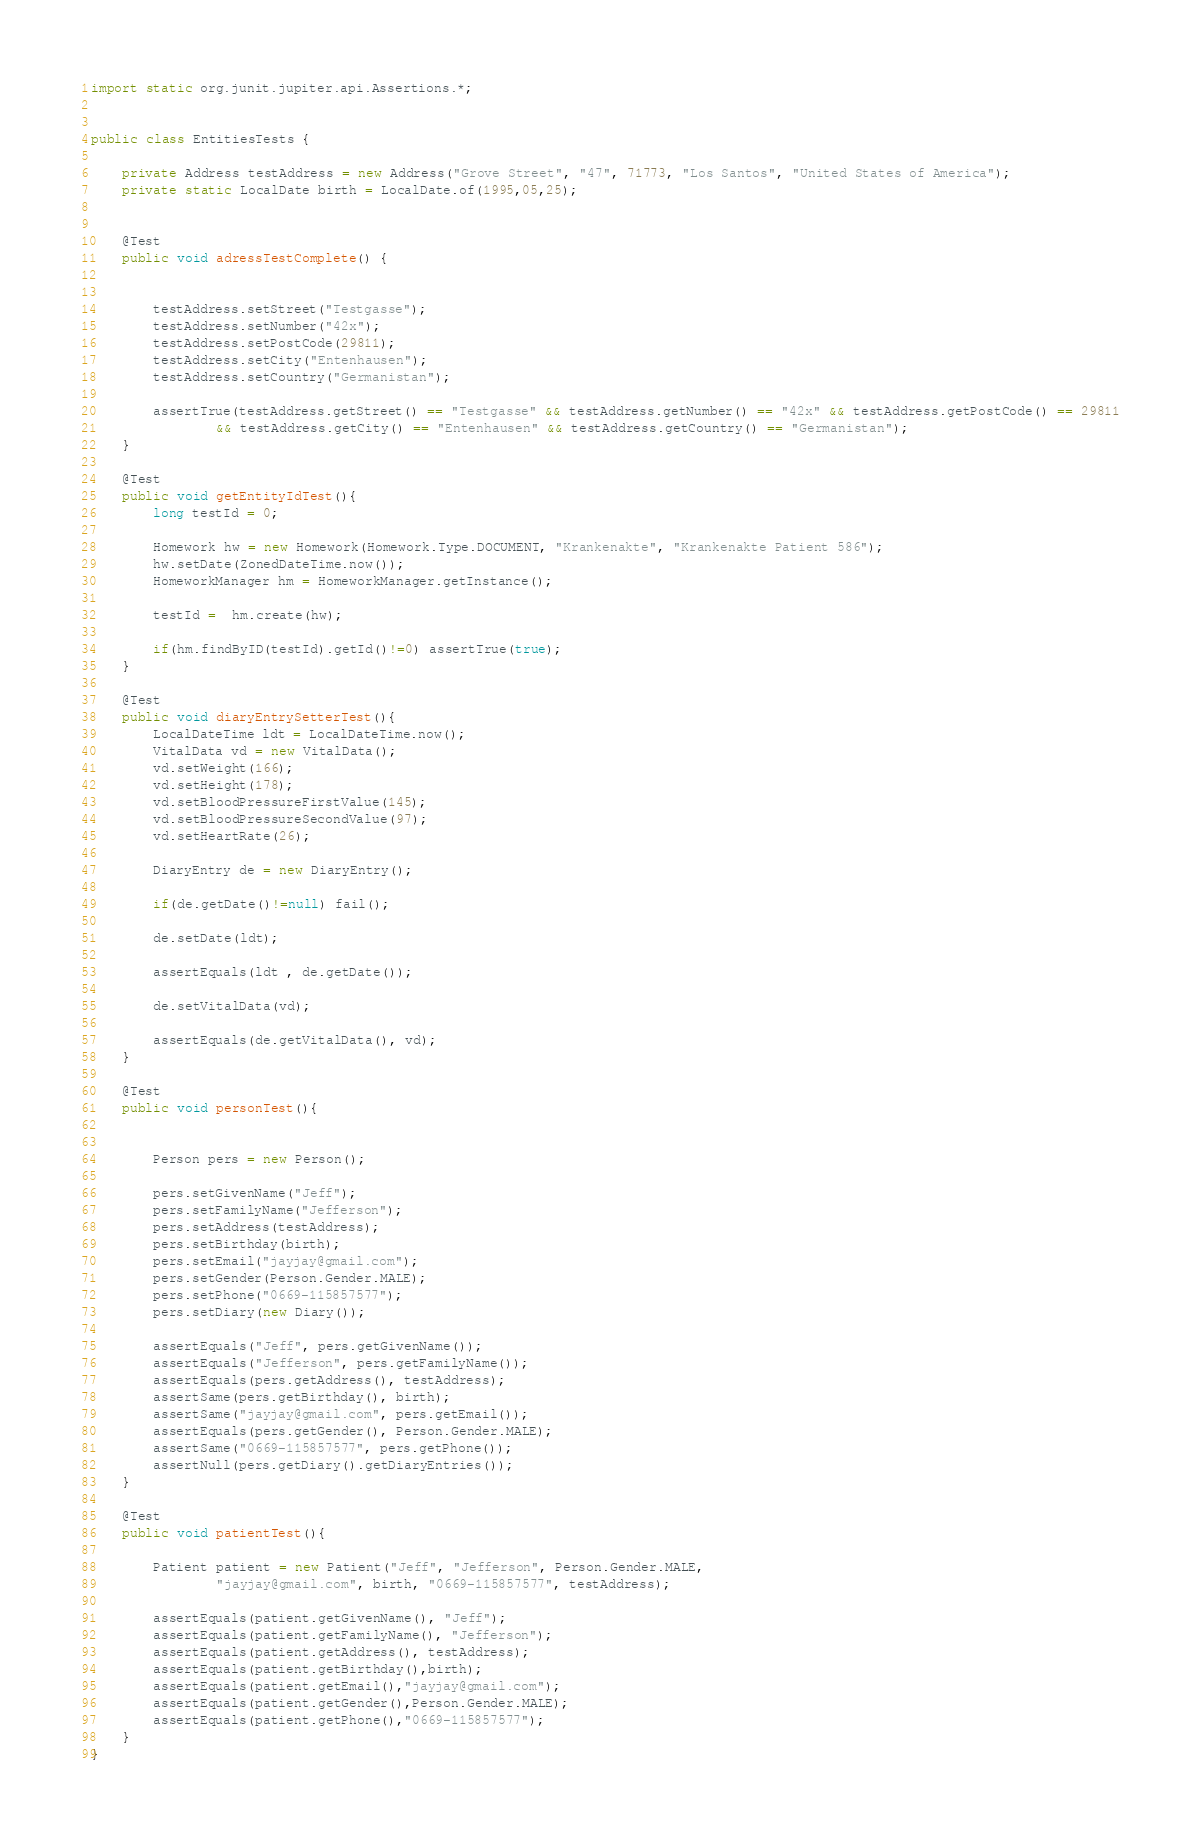Convert code to text. <code><loc_0><loc_0><loc_500><loc_500><_Java_>import static org.junit.jupiter.api.Assertions.*;


public class EntitiesTests {

    private Address testAddress = new Address("Grove Street", "47", 71773, "Los Santos", "United States of America");
    private static LocalDate birth = LocalDate.of(1995,05,25);


    @Test
    public void adressTestComplete() {


        testAddress.setStreet("Testgasse");
        testAddress.setNumber("42x");
        testAddress.setPostCode(29811);
        testAddress.setCity("Entenhausen");
        testAddress.setCountry("Germanistan");

        assertTrue(testAddress.getStreet() == "Testgasse" && testAddress.getNumber() == "42x" && testAddress.getPostCode() == 29811
                && testAddress.getCity() == "Entenhausen" && testAddress.getCountry() == "Germanistan");
    }

    @Test
    public void getEntityIdTest(){
        long testId = 0;

        Homework hw = new Homework(Homework.Type.DOCUMENT, "Krankenakte", "Krankenakte Patient 586");
        hw.setDate(ZonedDateTime.now());
        HomeworkManager hm = HomeworkManager.getInstance();

        testId =  hm.create(hw);

        if(hm.findByID(testId).getId()!=0) assertTrue(true);
    }

    @Test
    public void diaryEntrySetterTest(){
        LocalDateTime ldt = LocalDateTime.now();
        VitalData vd = new VitalData();
        vd.setWeight(166);
        vd.setHeight(178);
        vd.setBloodPressureFirstValue(145);
        vd.setBloodPressureSecondValue(97);
        vd.setHeartRate(26);

        DiaryEntry de = new DiaryEntry();

        if(de.getDate()!=null) fail();

        de.setDate(ldt);

        assertEquals(ldt , de.getDate());

        de.setVitalData(vd);

        assertEquals(de.getVitalData(), vd);
    }

    @Test
    public void personTest(){


        Person pers = new Person();

        pers.setGivenName("Jeff");
        pers.setFamilyName("Jefferson");
        pers.setAddress(testAddress);
        pers.setBirthday(birth);
        pers.setEmail("jayjay@gmail.com");
        pers.setGender(Person.Gender.MALE);
        pers.setPhone("0669-115857577");
        pers.setDiary(new Diary());

        assertEquals("Jeff", pers.getGivenName());
        assertEquals("Jefferson", pers.getFamilyName());
        assertEquals(pers.getAddress(), testAddress);
        assertSame(pers.getBirthday(), birth);
        assertSame("jayjay@gmail.com", pers.getEmail());
        assertEquals(pers.getGender(), Person.Gender.MALE);
        assertSame("0669-115857577", pers.getPhone());
        assertNull(pers.getDiary().getDiaryEntries());
    }

    @Test
    public void patientTest(){

        Patient patient = new Patient("Jeff", "Jefferson", Person.Gender.MALE,
                "jayjay@gmail.com", birth, "0669-115857577", testAddress);

        assertEquals(patient.getGivenName(), "Jeff");
        assertEquals(patient.getFamilyName(), "Jefferson");
        assertEquals(patient.getAddress(), testAddress);
        assertEquals(patient.getBirthday(),birth);
        assertEquals(patient.getEmail(),"jayjay@gmail.com");
        assertEquals(patient.getGender(),Person.Gender.MALE);
        assertEquals(patient.getPhone(),"0669-115857577");
    }
}</code> 